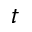<formula> <loc_0><loc_0><loc_500><loc_500>t</formula> 